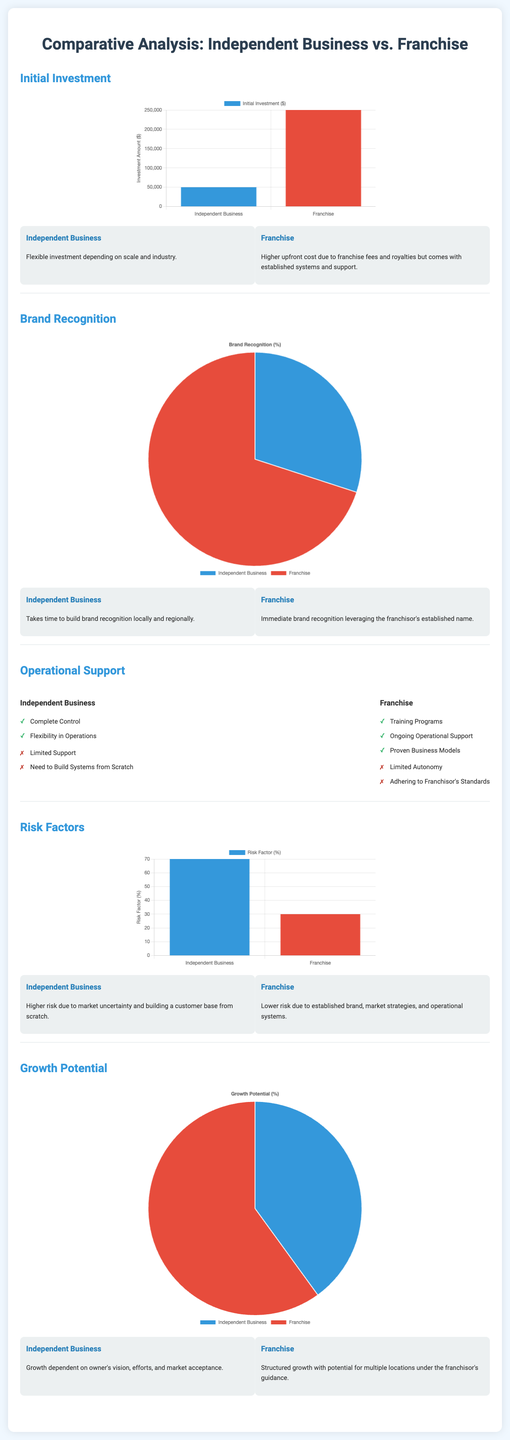What is the initial investment for an independent business? The initial investment for an independent business is $50,000 as shown in the bar chart of initial investments.
Answer: $50,000 What is the initial investment for a franchise? The initial investment for a franchise is represented as $250,000 in the same bar chart.
Answer: $250,000 What percentage of brand recognition does an independent business have? The pie chart indicates that an independent business has 30% brand recognition.
Answer: 30% What percentage of brand recognition does a franchise have? The franchise's brand recognition is shown as 70% in the pie chart.
Answer: 70% What is the risk factor percentage for an independent business? The chart for risk factors states that the risk factor for an independent business is 70%.
Answer: 70% What is the risk factor percentage for a franchise? The risk factor for a franchise is displayed as 30% in the chart.
Answer: 30% What are the operational support training programs listed for franchises? The operational support for franchises includes training programs, ongoing operational support, and proven business models.
Answer: Training programs, ongoing operational support, proven business models Which type of business has more growth potential according to the infographic? The infographic indicates that a franchise has more growth potential than an independent business, with a 60% versus 40% share in the pie chart.
Answer: Franchise What is one key disadvantage of running an independent business mentioned in the document? The document lists limited support as a key disadvantage for independent businesses in the pros and cons section.
Answer: Limited support What is one key advantage of operating a franchise? One key advantage of operating a franchise is ongoing operational support, as stated in the pros list.
Answer: Ongoing operational support 